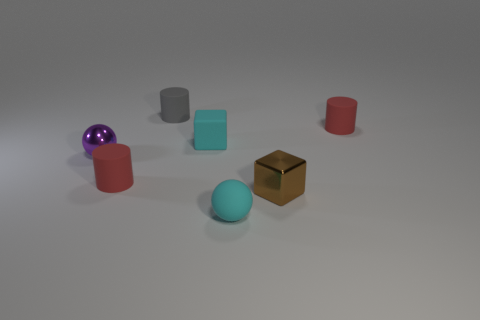How would you describe the aesthetic of this composition? The aesthetic of the composition is minimalist and modern, with the focus on the simple geometric shapes and muted colors. Each object's texture and material are clearly visible, emphasizing their individual characteristics over a neutral background that does not distract from their forms. 